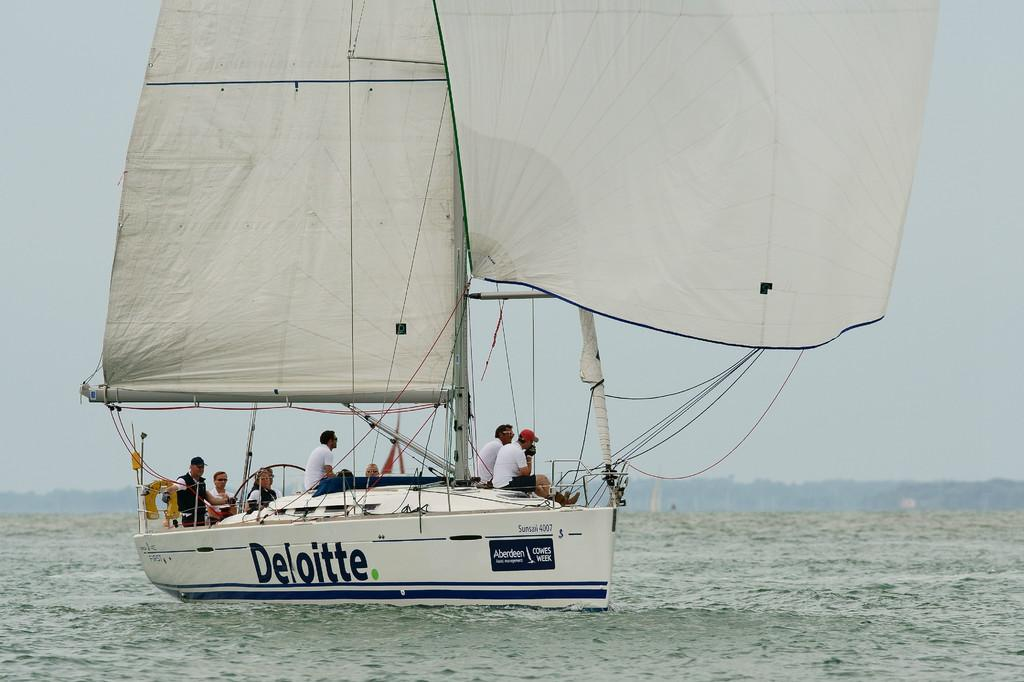What are the people in the image doing? There are persons sitting on a boat in the image. Where is the boat located? The boat is on the water. What can be seen on the boat? There are curtains on poles and strings visible in the image. What is visible in the background of the image? There are trees and the sky visible in the background of the image. What type of poison can be seen in the image? There is no poison present in the image. Is there a stranger sitting on the boat with the persons in the image? The image does not show any strangers; it only shows the persons sitting on the boat. 